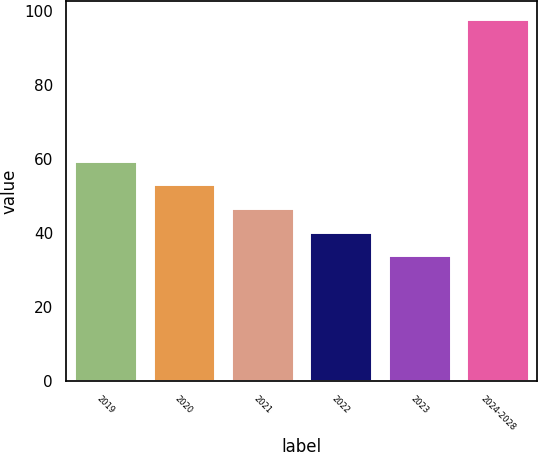Convert chart to OTSL. <chart><loc_0><loc_0><loc_500><loc_500><bar_chart><fcel>2019<fcel>2020<fcel>2021<fcel>2022<fcel>2023<fcel>2024-2028<nl><fcel>59.6<fcel>53.2<fcel>46.8<fcel>40.4<fcel>34<fcel>98<nl></chart> 